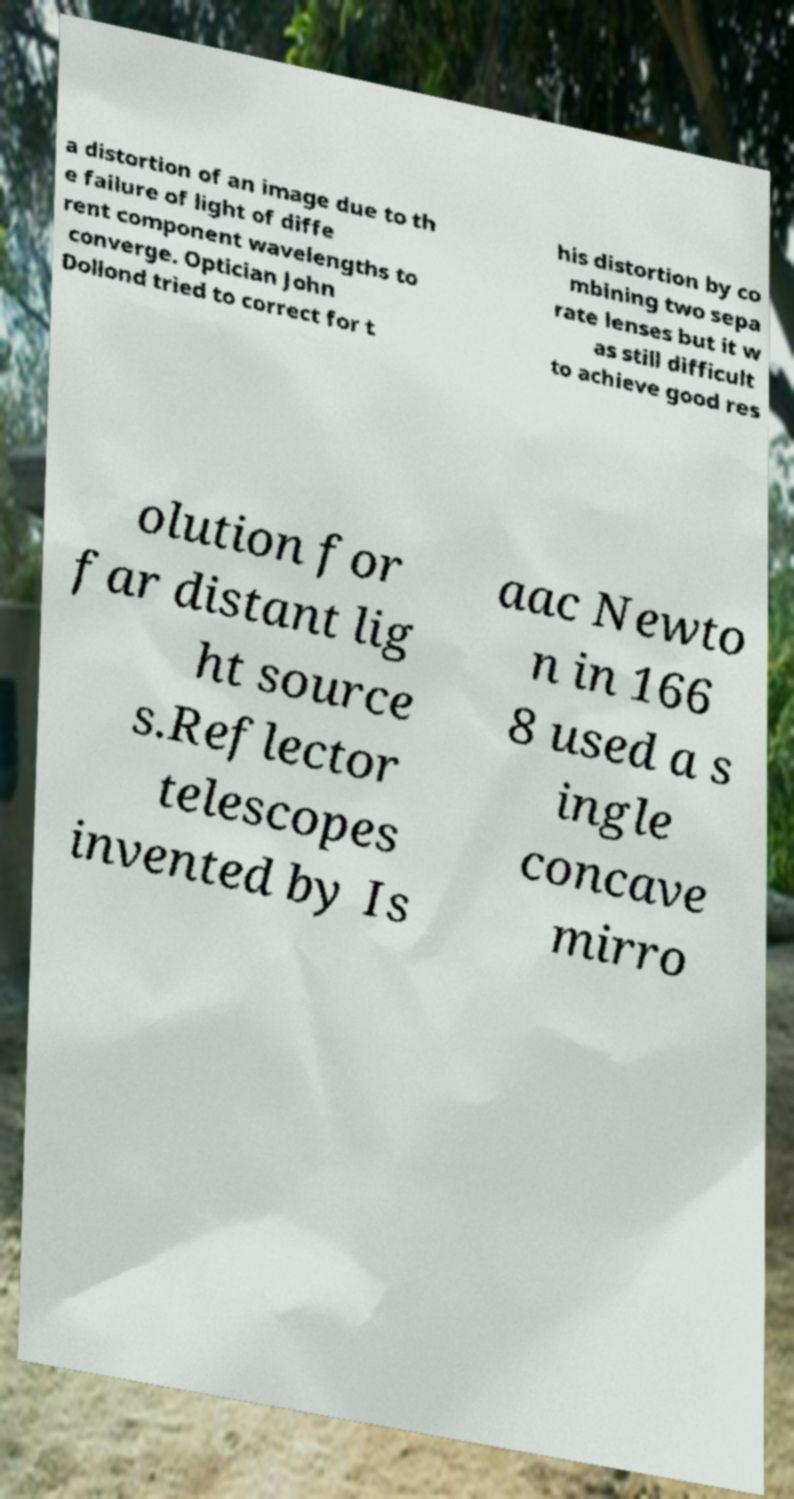Could you extract and type out the text from this image? a distortion of an image due to th e failure of light of diffe rent component wavelengths to converge. Optician John Dollond tried to correct for t his distortion by co mbining two sepa rate lenses but it w as still difficult to achieve good res olution for far distant lig ht source s.Reflector telescopes invented by Is aac Newto n in 166 8 used a s ingle concave mirro 